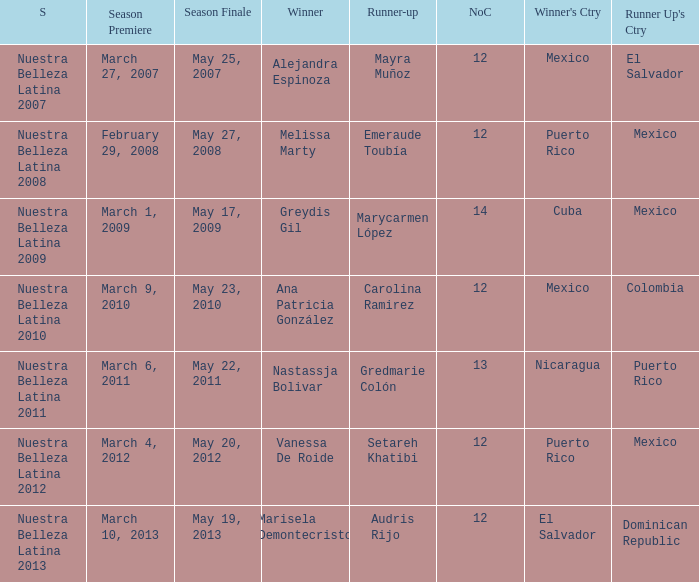I'm looking to parse the entire table for insights. Could you assist me with that? {'header': ['S', 'Season Premiere', 'Season Finale', 'Winner', 'Runner-up', 'NoC', "Winner's Ctry", "Runner Up's Ctry"], 'rows': [['Nuestra Belleza Latina 2007', 'March 27, 2007', 'May 25, 2007', 'Alejandra Espinoza', 'Mayra Muñoz', '12', 'Mexico', 'El Salvador'], ['Nuestra Belleza Latina 2008', 'February 29, 2008', 'May 27, 2008', 'Melissa Marty', 'Emeraude Toubía', '12', 'Puerto Rico', 'Mexico'], ['Nuestra Belleza Latina 2009', 'March 1, 2009', 'May 17, 2009', 'Greydis Gil', 'Marycarmen López', '14', 'Cuba', 'Mexico'], ['Nuestra Belleza Latina 2010', 'March 9, 2010', 'May 23, 2010', 'Ana Patricia González', 'Carolina Ramirez', '12', 'Mexico', 'Colombia'], ['Nuestra Belleza Latina 2011', 'March 6, 2011', 'May 22, 2011', 'Nastassja Bolivar', 'Gredmarie Colón', '13', 'Nicaragua', 'Puerto Rico'], ['Nuestra Belleza Latina 2012', 'March 4, 2012', 'May 20, 2012', 'Vanessa De Roide', 'Setareh Khatibi', '12', 'Puerto Rico', 'Mexico'], ['Nuestra Belleza Latina 2013', 'March 10, 2013', 'May 19, 2013', 'Marisela Demontecristo', 'Audris Rijo', '12', 'El Salvador', 'Dominican Republic']]} What season had mexico as the runner up with melissa marty winning? Nuestra Belleza Latina 2008. 